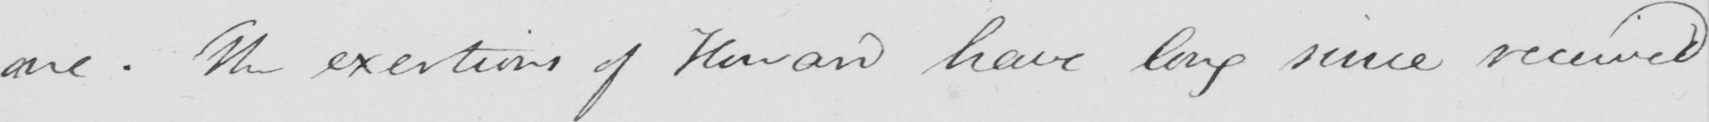Please provide the text content of this handwritten line. one . The exertrions of Howard have long since received 